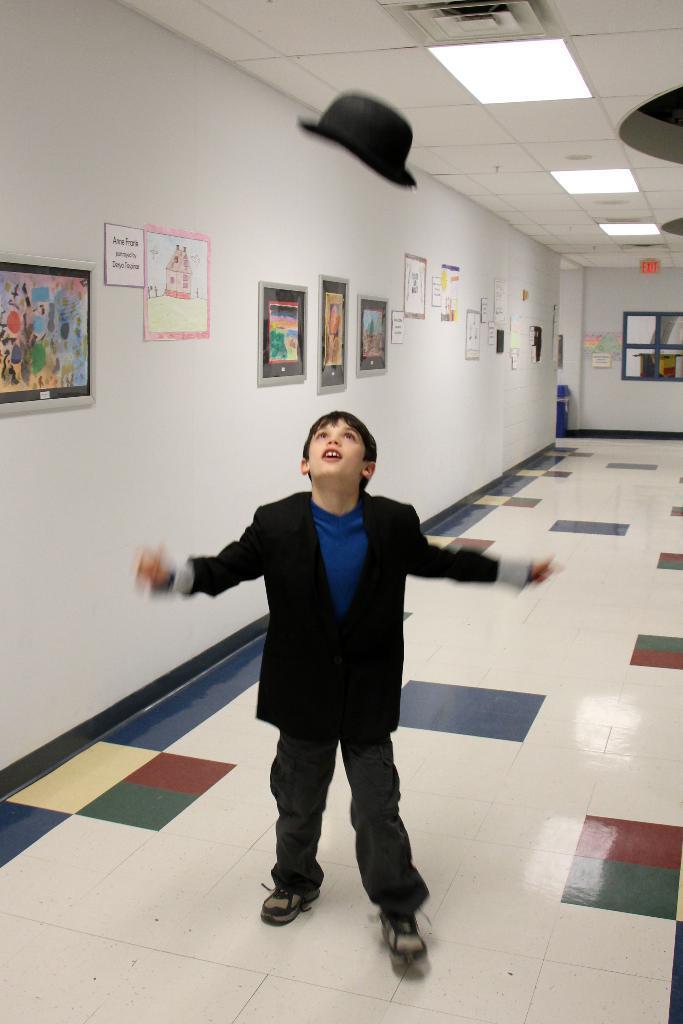Could you give a brief overview of what you see in this image? In this image we can see a boy standing on the floor, there are some photo frames and posters on the wall, at the top of the roof we can see lights and also we can see a hat. 